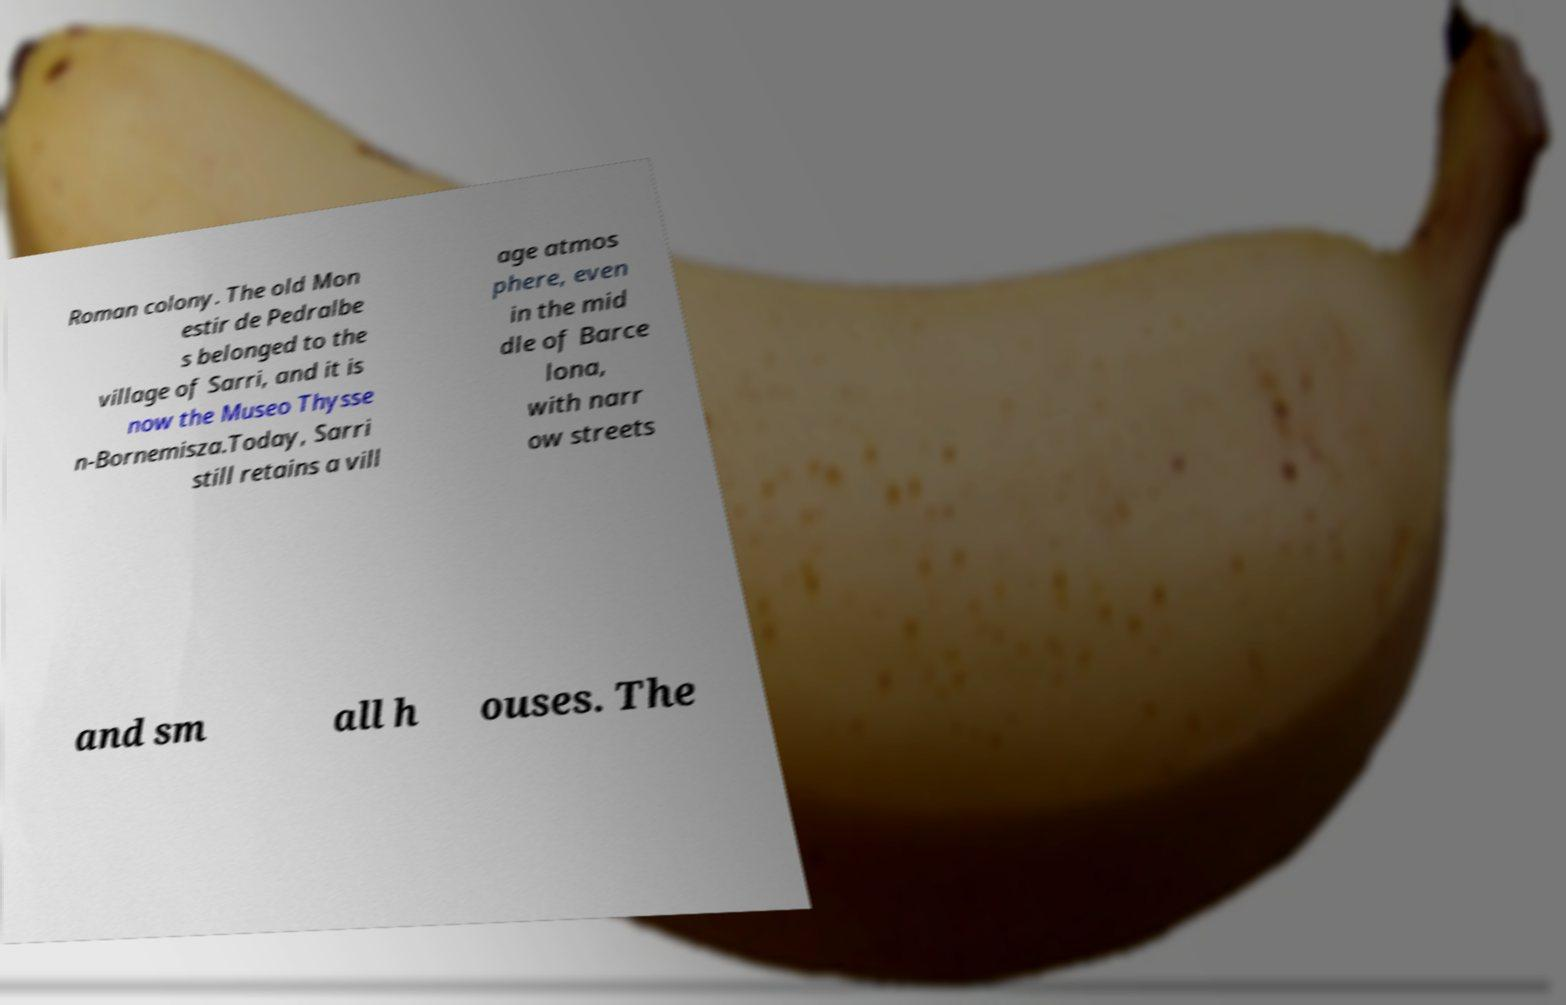Could you assist in decoding the text presented in this image and type it out clearly? Roman colony. The old Mon estir de Pedralbe s belonged to the village of Sarri, and it is now the Museo Thysse n-Bornemisza.Today, Sarri still retains a vill age atmos phere, even in the mid dle of Barce lona, with narr ow streets and sm all h ouses. The 